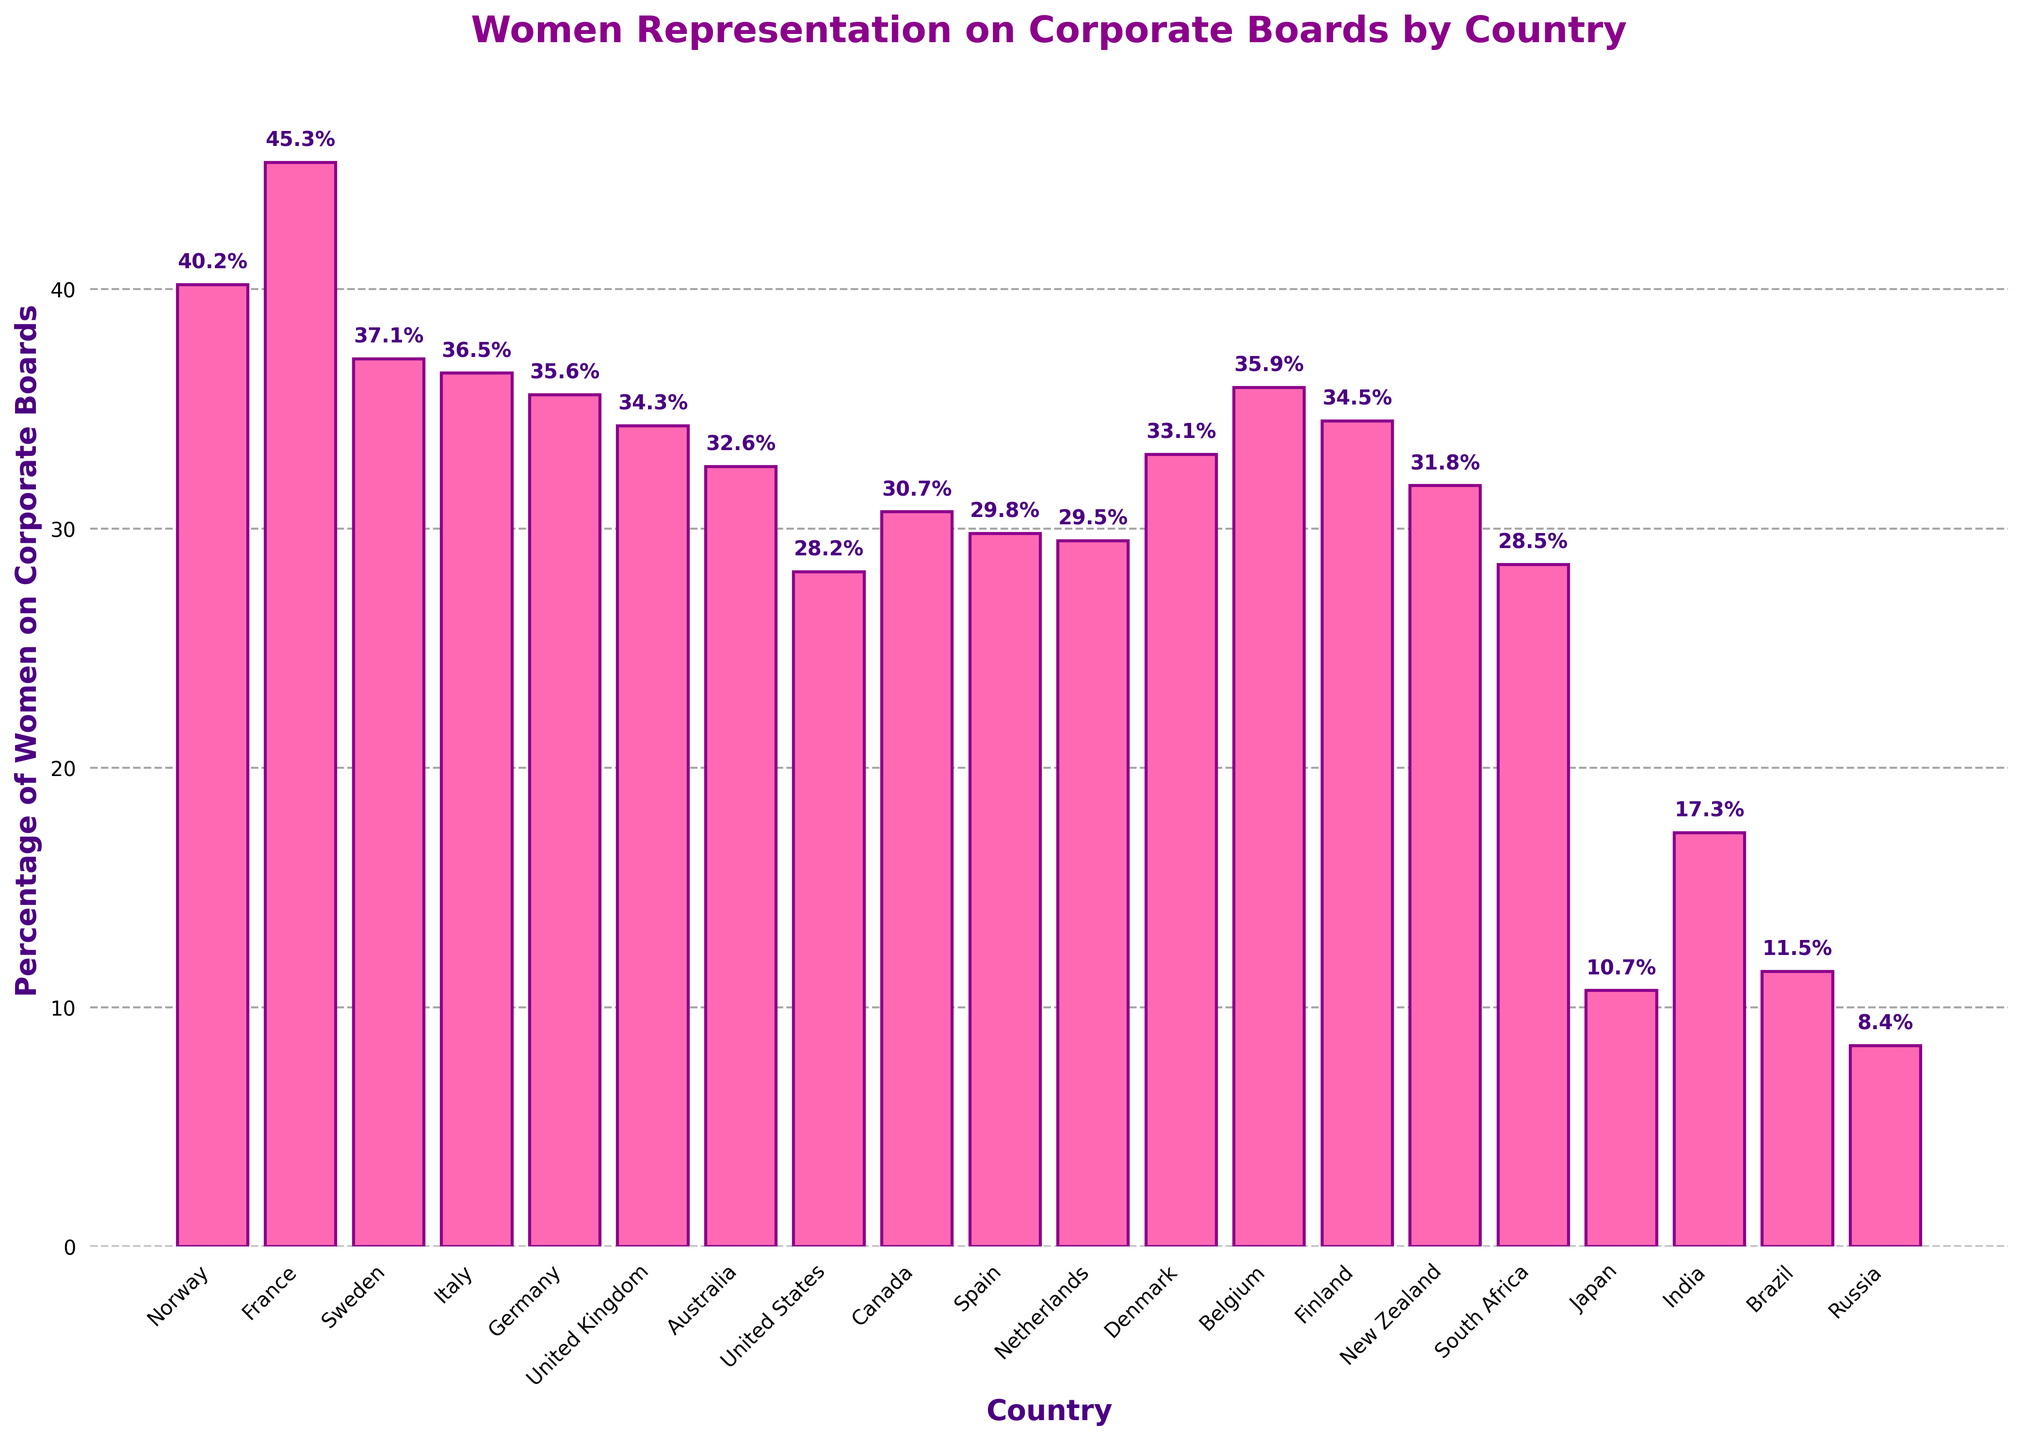Which country has the highest percentage of women on corporate boards? To find the country with the highest percentage, look for the tallest bar in the chart. France has the highest percentage at 45.3%
Answer: France Compare the percentage of women on corporate boards in Norway and Japan. Which has a higher percentage and by how much? To compare, note the values: Norway (40.2%), Japan (10.7%). Subtract the smaller percentage from the larger one: 40.2 - 10.7 = 29.5
Answer: Norway by 29.5% What is the difference in percentage of women on corporate boards between the United States and Canada? Identify the values for both countries: United States (28.2%), Canada (30.7%). Subtract the smaller value from the larger: 30.7 - 28.2 = 2.5
Answer: 2.5 What is the average percentage of women on corporate boards for the three countries with the highest values? The top three are France (45.3%), Norway (40.2%), and Sweden (37.1%). Calculate the average: (45.3 + 40.2 + 37.1) / 3 = 40.8667
Answer: 40.87 Which country has the lowest percentage of women on corporate boards? To find the country with the lowest percentage, look for the shortest bar. Russia has the lowest percentage at 8.4%
Answer: Russia Which country has a percentage of women on corporate boards closest to 30%? Identify the percentages closest to 30%: Canada (30.7%), Spain (29.8%), Netherlands (29.5%). Spain's 29.8% is the closest to 30%
Answer: Spain How many countries have a percentage of women on corporate boards greater than 35%? List the countries: France (45.3%), Norway (40.2%), Sweden (37.1%), Italy (36.5%), Germany (35.6%), Belgium (35.9%). There are 6 countries
Answer: 6 What is the combined percentage of women on corporate boards for Denmark and New Zealand? Add the percentages for both countries: Denmark (33.1%), New Zealand (31.8%). Calculate the total: 33.1 + 31.8 = 64.9
Answer: 64.9 How does the percentage of women on corporate boards in Australia compare to that in the United Kingdom? Identify the values: Australia (32.6%), United Kingdom (34.3%). The United Kingdom has a higher percentage by 34.3 - 32.6 = 1.7
Answer: United Kingdom by 1.7 What is the median percentage of women on corporate boards? List all percentages in ascending order and find the middle value. There are 20 countries, so the median is the average of the 10th and 11th values: (29.8 + 30.7) / 2 = 30.25
Answer: 30.25 